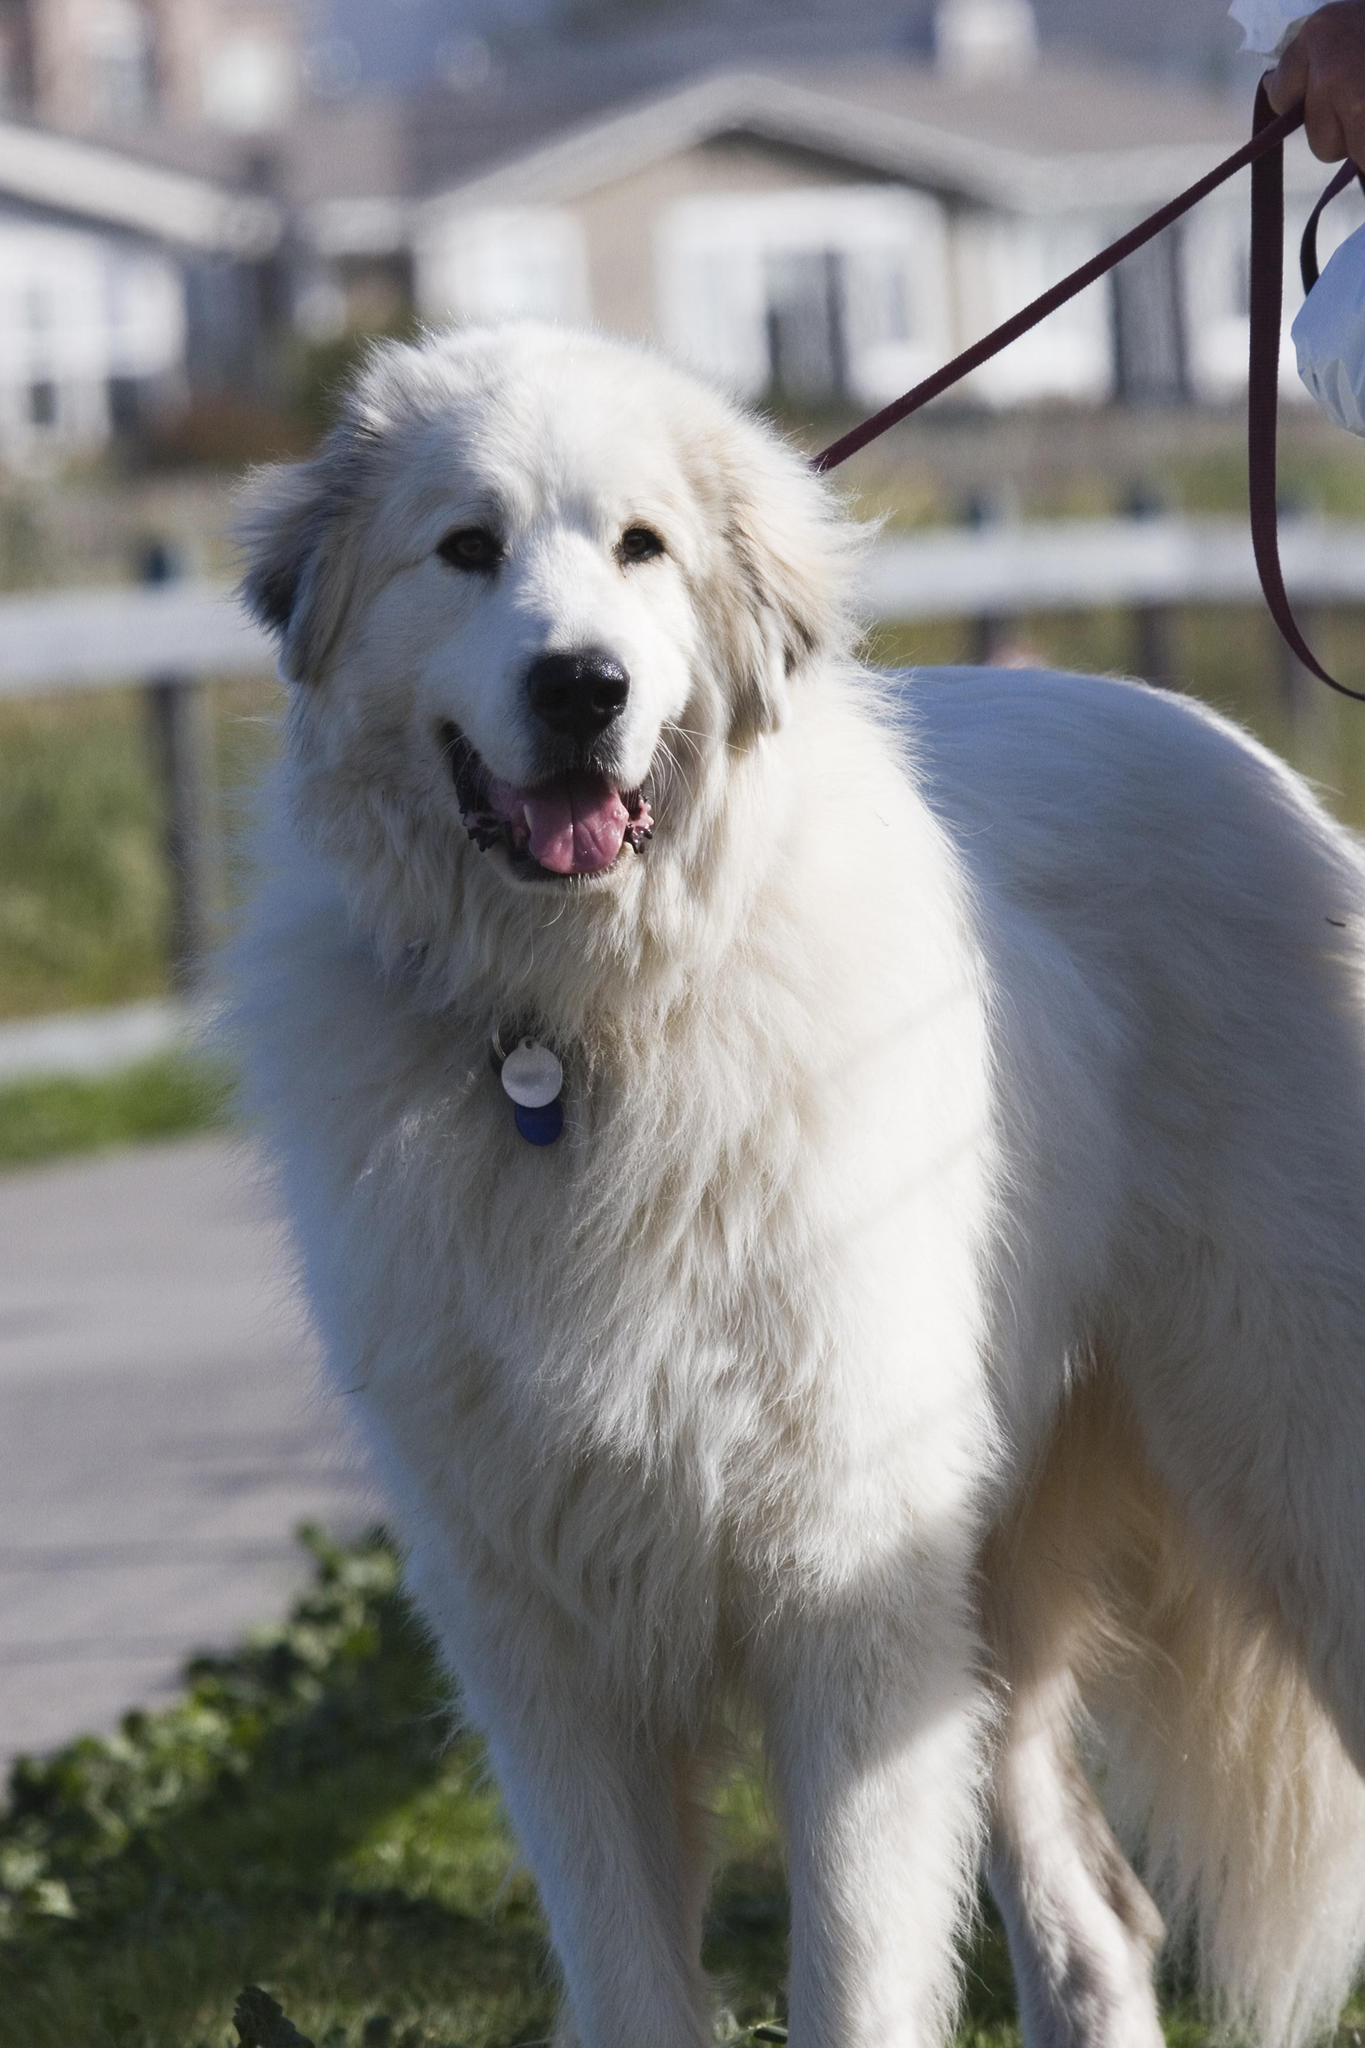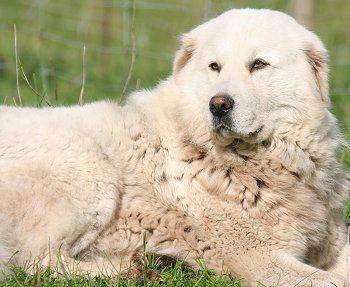The first image is the image on the left, the second image is the image on the right. Examine the images to the left and right. Is the description "If one dog is lying down, there are no sitting dogs near them." accurate? Answer yes or no. Yes. The first image is the image on the left, the second image is the image on the right. Considering the images on both sides, is "There is a single, white dog lying down in the right image." valid? Answer yes or no. Yes. 